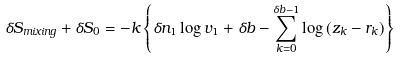Convert formula to latex. <formula><loc_0><loc_0><loc_500><loc_500>\delta S _ { m i x i n g } + \delta S _ { 0 } = - k \left \{ \delta n _ { 1 } \log v _ { 1 } + \delta b - \sum _ { k = 0 } ^ { \delta b - 1 } \log \, ( z _ { k } - r _ { k } ) \right \}</formula> 